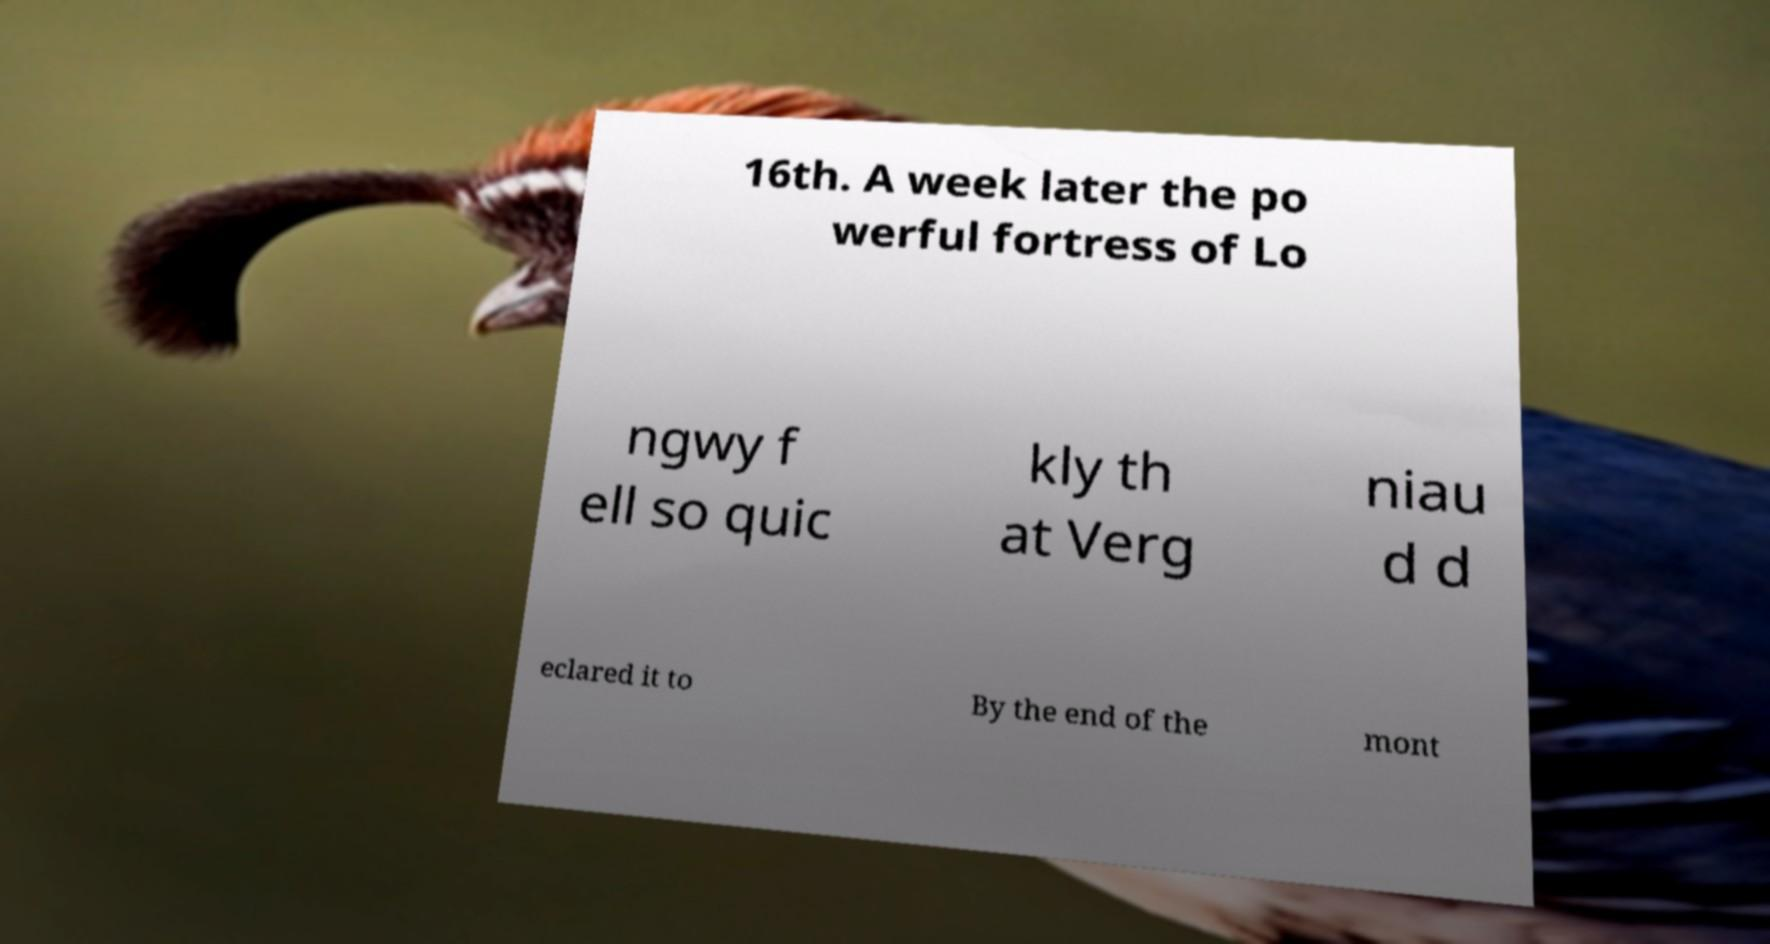What messages or text are displayed in this image? I need them in a readable, typed format. 16th. A week later the po werful fortress of Lo ngwy f ell so quic kly th at Verg niau d d eclared it to By the end of the mont 